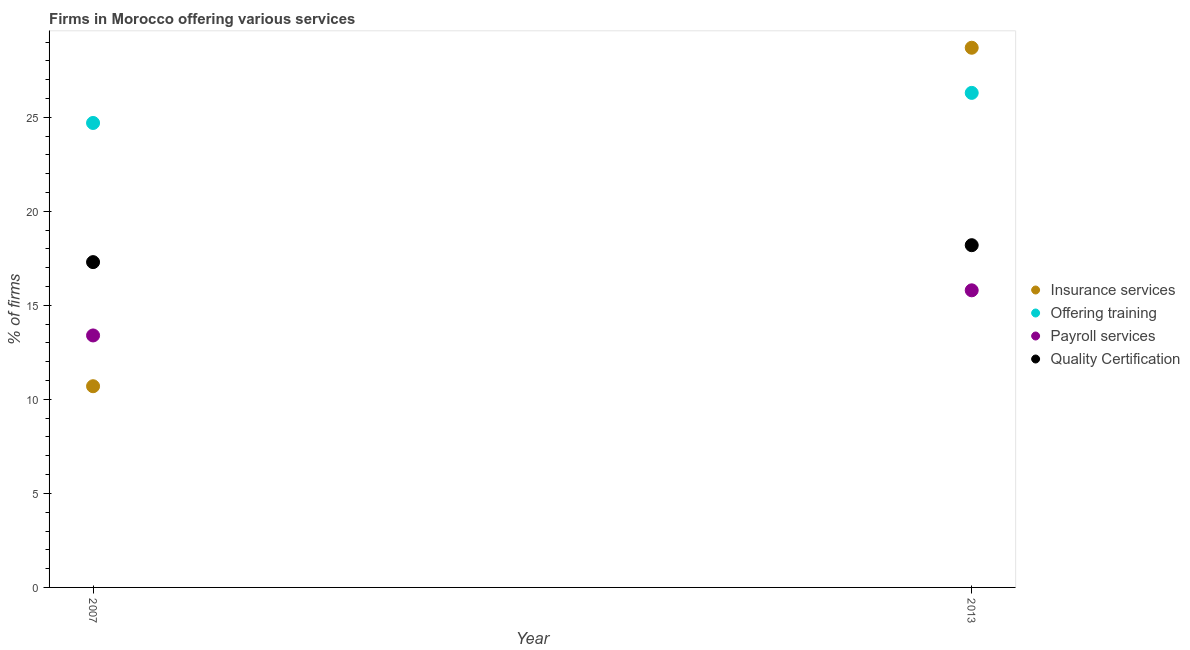Is the number of dotlines equal to the number of legend labels?
Give a very brief answer. Yes. Across all years, what is the maximum percentage of firms offering insurance services?
Your response must be concise. 28.7. Across all years, what is the minimum percentage of firms offering training?
Your response must be concise. 24.7. What is the difference between the percentage of firms offering training in 2007 and that in 2013?
Offer a very short reply. -1.6. In how many years, is the percentage of firms offering quality certification greater than 28 %?
Provide a short and direct response. 0. What is the ratio of the percentage of firms offering quality certification in 2007 to that in 2013?
Make the answer very short. 0.95. Is the percentage of firms offering training in 2007 less than that in 2013?
Offer a terse response. Yes. In how many years, is the percentage of firms offering insurance services greater than the average percentage of firms offering insurance services taken over all years?
Make the answer very short. 1. Is it the case that in every year, the sum of the percentage of firms offering quality certification and percentage of firms offering payroll services is greater than the sum of percentage of firms offering training and percentage of firms offering insurance services?
Provide a short and direct response. No. Is it the case that in every year, the sum of the percentage of firms offering insurance services and percentage of firms offering training is greater than the percentage of firms offering payroll services?
Provide a short and direct response. Yes. Is the percentage of firms offering payroll services strictly greater than the percentage of firms offering insurance services over the years?
Keep it short and to the point. No. What is the difference between two consecutive major ticks on the Y-axis?
Provide a succinct answer. 5. Are the values on the major ticks of Y-axis written in scientific E-notation?
Offer a terse response. No. Does the graph contain any zero values?
Your answer should be very brief. No. Does the graph contain grids?
Give a very brief answer. No. How many legend labels are there?
Your response must be concise. 4. What is the title of the graph?
Provide a succinct answer. Firms in Morocco offering various services . Does "Labor Taxes" appear as one of the legend labels in the graph?
Offer a terse response. No. What is the label or title of the Y-axis?
Offer a very short reply. % of firms. What is the % of firms of Offering training in 2007?
Ensure brevity in your answer.  24.7. What is the % of firms of Payroll services in 2007?
Provide a short and direct response. 13.4. What is the % of firms of Insurance services in 2013?
Keep it short and to the point. 28.7. What is the % of firms of Offering training in 2013?
Ensure brevity in your answer.  26.3. Across all years, what is the maximum % of firms of Insurance services?
Make the answer very short. 28.7. Across all years, what is the maximum % of firms in Offering training?
Your answer should be very brief. 26.3. Across all years, what is the maximum % of firms in Quality Certification?
Provide a short and direct response. 18.2. Across all years, what is the minimum % of firms of Offering training?
Offer a very short reply. 24.7. Across all years, what is the minimum % of firms in Quality Certification?
Offer a terse response. 17.3. What is the total % of firms of Insurance services in the graph?
Offer a very short reply. 39.4. What is the total % of firms in Offering training in the graph?
Your answer should be very brief. 51. What is the total % of firms in Payroll services in the graph?
Make the answer very short. 29.2. What is the total % of firms in Quality Certification in the graph?
Keep it short and to the point. 35.5. What is the difference between the % of firms in Payroll services in 2007 and that in 2013?
Offer a very short reply. -2.4. What is the difference between the % of firms in Quality Certification in 2007 and that in 2013?
Ensure brevity in your answer.  -0.9. What is the difference between the % of firms of Insurance services in 2007 and the % of firms of Offering training in 2013?
Give a very brief answer. -15.6. What is the difference between the % of firms of Insurance services in 2007 and the % of firms of Payroll services in 2013?
Offer a terse response. -5.1. What is the difference between the % of firms in Offering training in 2007 and the % of firms in Payroll services in 2013?
Provide a short and direct response. 8.9. What is the difference between the % of firms in Offering training in 2007 and the % of firms in Quality Certification in 2013?
Your response must be concise. 6.5. What is the difference between the % of firms in Payroll services in 2007 and the % of firms in Quality Certification in 2013?
Offer a very short reply. -4.8. What is the average % of firms in Insurance services per year?
Provide a short and direct response. 19.7. What is the average % of firms of Quality Certification per year?
Give a very brief answer. 17.75. In the year 2007, what is the difference between the % of firms of Offering training and % of firms of Quality Certification?
Offer a terse response. 7.4. In the year 2013, what is the difference between the % of firms of Insurance services and % of firms of Offering training?
Your answer should be compact. 2.4. What is the ratio of the % of firms in Insurance services in 2007 to that in 2013?
Offer a very short reply. 0.37. What is the ratio of the % of firms in Offering training in 2007 to that in 2013?
Your answer should be compact. 0.94. What is the ratio of the % of firms in Payroll services in 2007 to that in 2013?
Provide a succinct answer. 0.85. What is the ratio of the % of firms of Quality Certification in 2007 to that in 2013?
Your answer should be compact. 0.95. What is the difference between the highest and the second highest % of firms of Insurance services?
Ensure brevity in your answer.  18. What is the difference between the highest and the second highest % of firms in Offering training?
Offer a terse response. 1.6. What is the difference between the highest and the second highest % of firms of Quality Certification?
Provide a short and direct response. 0.9. What is the difference between the highest and the lowest % of firms of Insurance services?
Provide a short and direct response. 18. What is the difference between the highest and the lowest % of firms of Payroll services?
Offer a terse response. 2.4. 